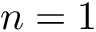<formula> <loc_0><loc_0><loc_500><loc_500>n = 1</formula> 